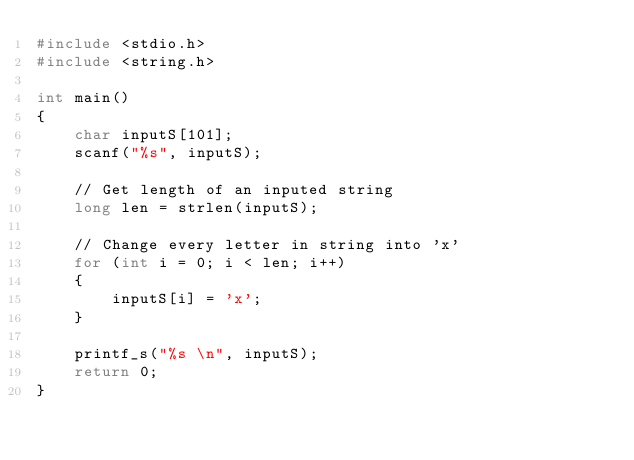<code> <loc_0><loc_0><loc_500><loc_500><_C_>#include <stdio.h>
#include <string.h>

int main()
{
	char inputS[101];
	scanf("%s", inputS);

	// Get length of an inputed string
	long len = strlen(inputS);

	// Change every letter in string into 'x'
	for (int i = 0; i < len; i++)
	{
		inputS[i] = 'x';
	}

	printf_s("%s \n", inputS);
	return 0;
}</code> 